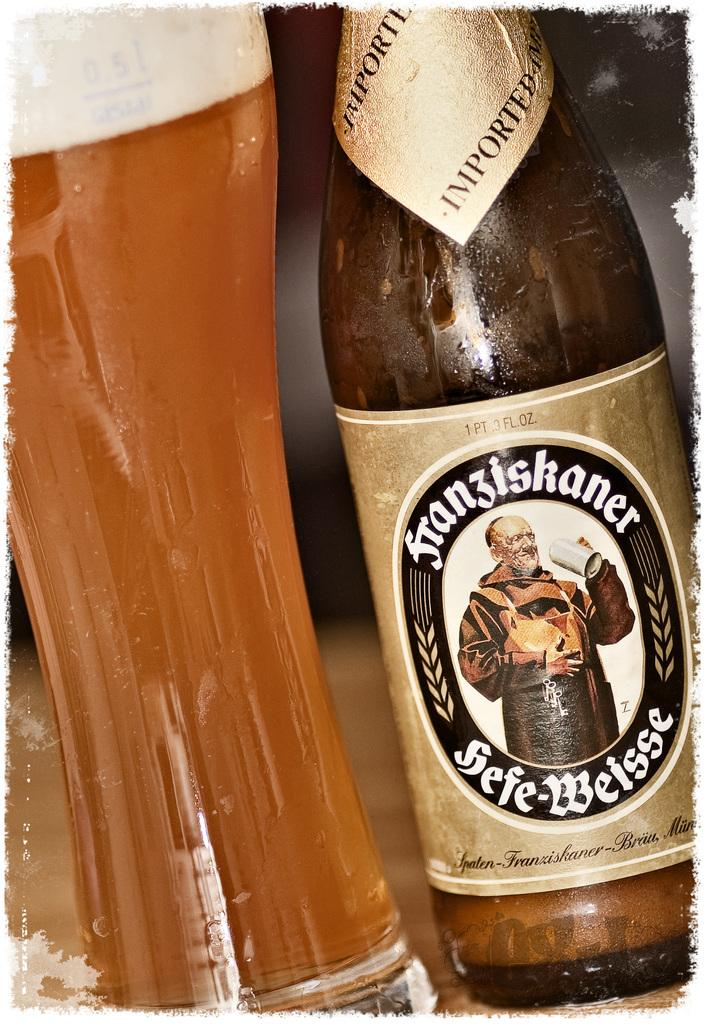<image>
Share a concise interpretation of the image provided. Hefe-Weisse beer bottle and a glass of beer. 